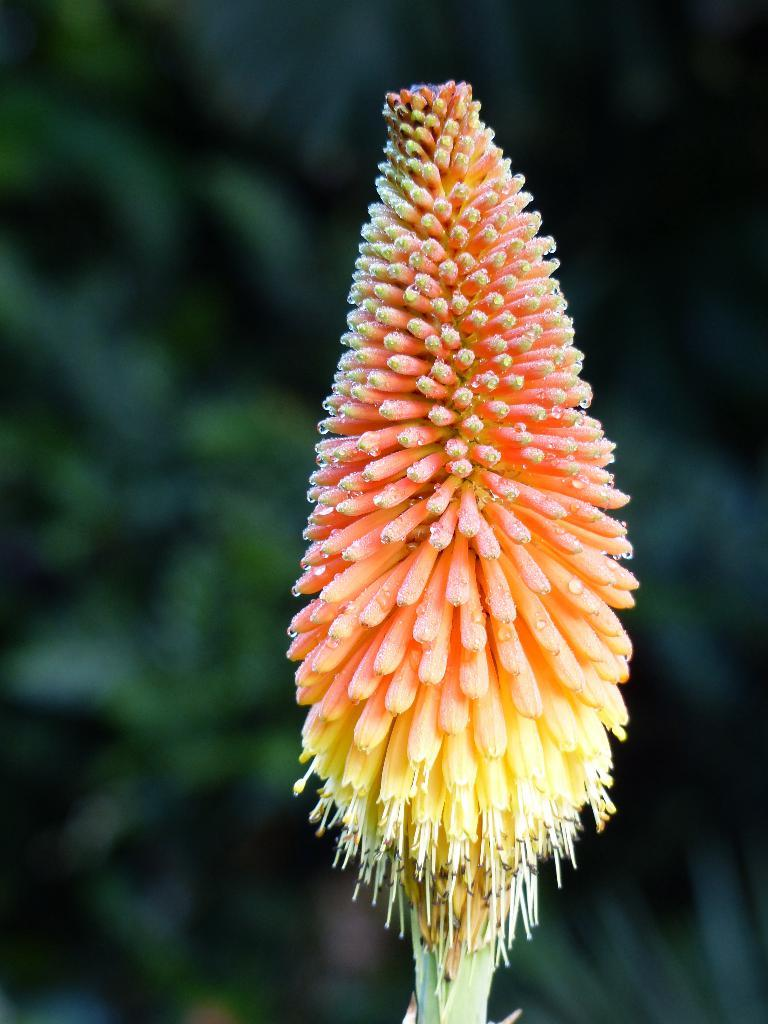What is the main subject of the image? The main subject of the image is a stem. What features can be observed on the stem? The stem has flowers and buds. How would you describe the background of the image? The background of the image is blurry. What type of skirt is hanging on the stem in the image? There is no skirt present in the image; it features a stem with flowers and buds. How does the cushion on the stem contribute to the overall aesthetic of the image? There is no cushion present in the image; it only features a stem with flowers and buds. 